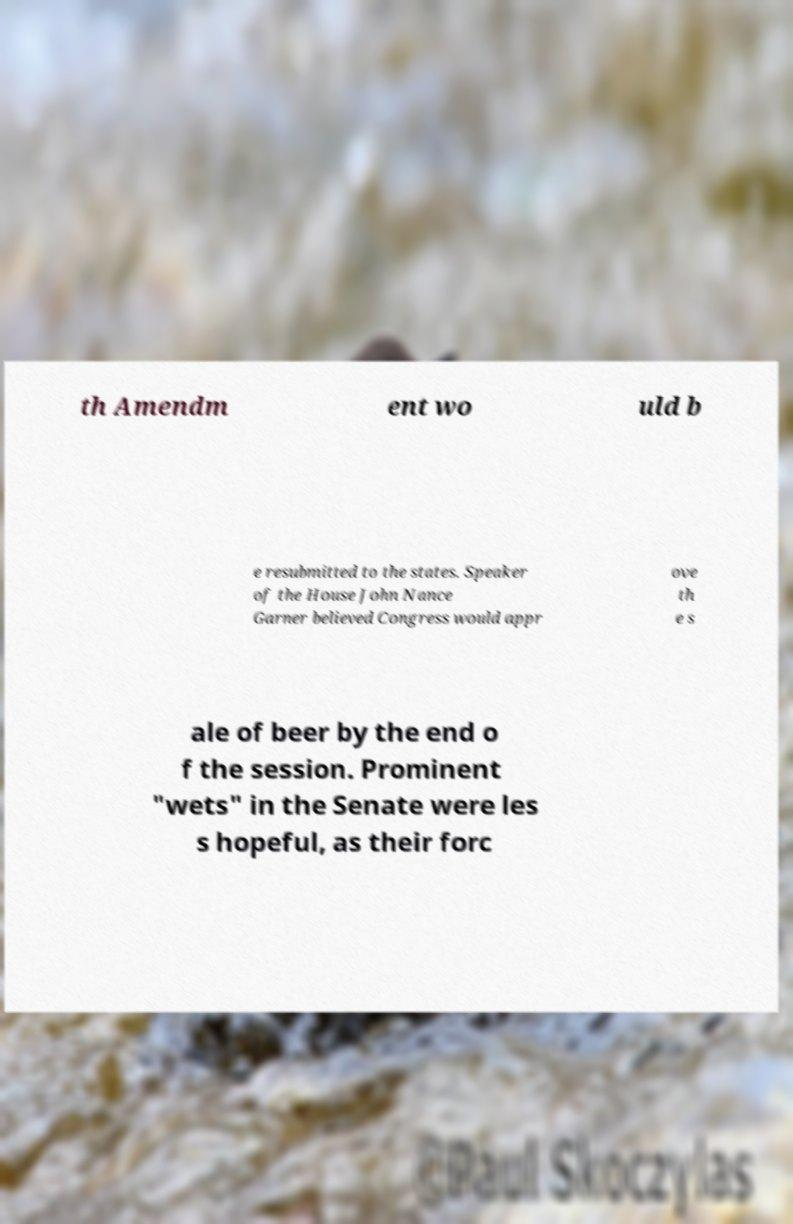Could you assist in decoding the text presented in this image and type it out clearly? th Amendm ent wo uld b e resubmitted to the states. Speaker of the House John Nance Garner believed Congress would appr ove th e s ale of beer by the end o f the session. Prominent "wets" in the Senate were les s hopeful, as their forc 